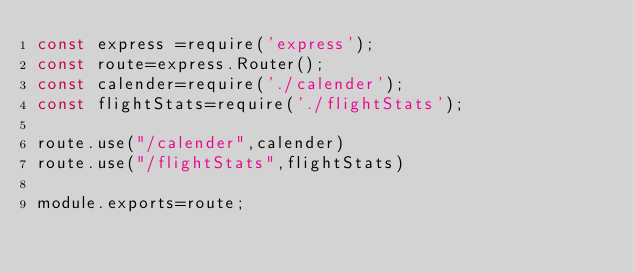<code> <loc_0><loc_0><loc_500><loc_500><_JavaScript_>const express =require('express');
const route=express.Router();
const calender=require('./calender');
const flightStats=require('./flightStats');

route.use("/calender",calender)
route.use("/flightStats",flightStats)

module.exports=route;</code> 